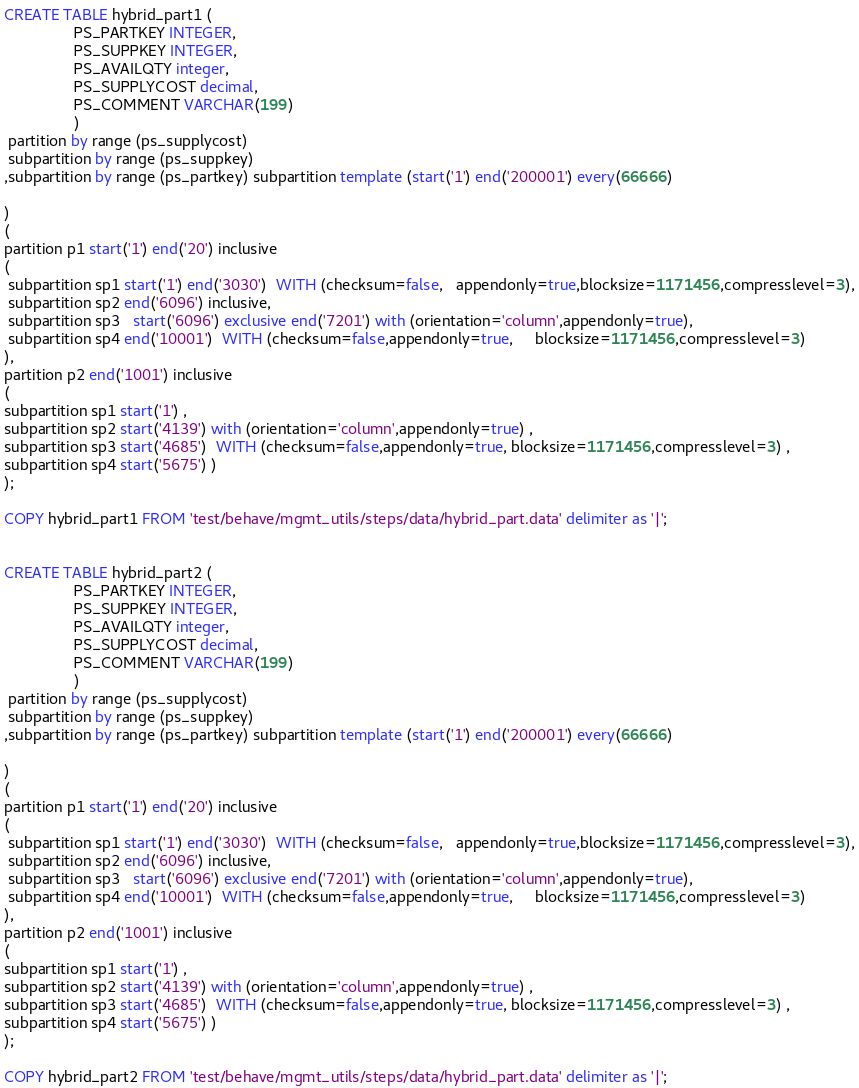<code> <loc_0><loc_0><loc_500><loc_500><_SQL_>CREATE TABLE hybrid_part1 (
                PS_PARTKEY INTEGER,
                PS_SUPPKEY INTEGER,
                PS_AVAILQTY integer,
                PS_SUPPLYCOST decimal,
                PS_COMMENT VARCHAR(199)
                ) 
 partition by range (ps_supplycost)
 subpartition by range (ps_suppkey)
,subpartition by range (ps_partkey) subpartition template (start('1') end('200001') every(66666)

)
(
partition p1 start('1') end('20') inclusive
(
 subpartition sp1 start('1') end('3030')  WITH (checksum=false,   appendonly=true,blocksize=1171456,compresslevel=3),
 subpartition sp2 end('6096') inclusive,
 subpartition sp3   start('6096') exclusive end('7201') with (orientation='column',appendonly=true),
 subpartition sp4 end('10001')  WITH (checksum=false,appendonly=true,     blocksize=1171456,compresslevel=3)
), 
partition p2 end('1001') inclusive
(
subpartition sp1 start('1') ,        
subpartition sp2 start('4139') with (orientation='column',appendonly=true) ,
subpartition sp3 start('4685')  WITH (checksum=false,appendonly=true, blocksize=1171456,compresslevel=3) ,
subpartition sp4 start('5675') )
);

COPY hybrid_part1 FROM 'test/behave/mgmt_utils/steps/data/hybrid_part.data' delimiter as '|';


CREATE TABLE hybrid_part2 (
                PS_PARTKEY INTEGER,
                PS_SUPPKEY INTEGER,
                PS_AVAILQTY integer,
                PS_SUPPLYCOST decimal,
                PS_COMMENT VARCHAR(199)
                ) 
 partition by range (ps_supplycost)
 subpartition by range (ps_suppkey)
,subpartition by range (ps_partkey) subpartition template (start('1') end('200001') every(66666)

)
(
partition p1 start('1') end('20') inclusive
(
 subpartition sp1 start('1') end('3030')  WITH (checksum=false,   appendonly=true,blocksize=1171456,compresslevel=3),
 subpartition sp2 end('6096') inclusive,
 subpartition sp3   start('6096') exclusive end('7201') with (orientation='column',appendonly=true),
 subpartition sp4 end('10001')  WITH (checksum=false,appendonly=true,     blocksize=1171456,compresslevel=3)
), 
partition p2 end('1001') inclusive
(
subpartition sp1 start('1') ,        
subpartition sp2 start('4139') with (orientation='column',appendonly=true) ,
subpartition sp3 start('4685')  WITH (checksum=false,appendonly=true, blocksize=1171456,compresslevel=3) ,
subpartition sp4 start('5675') )
);

COPY hybrid_part2 FROM 'test/behave/mgmt_utils/steps/data/hybrid_part.data' delimiter as '|';
</code> 